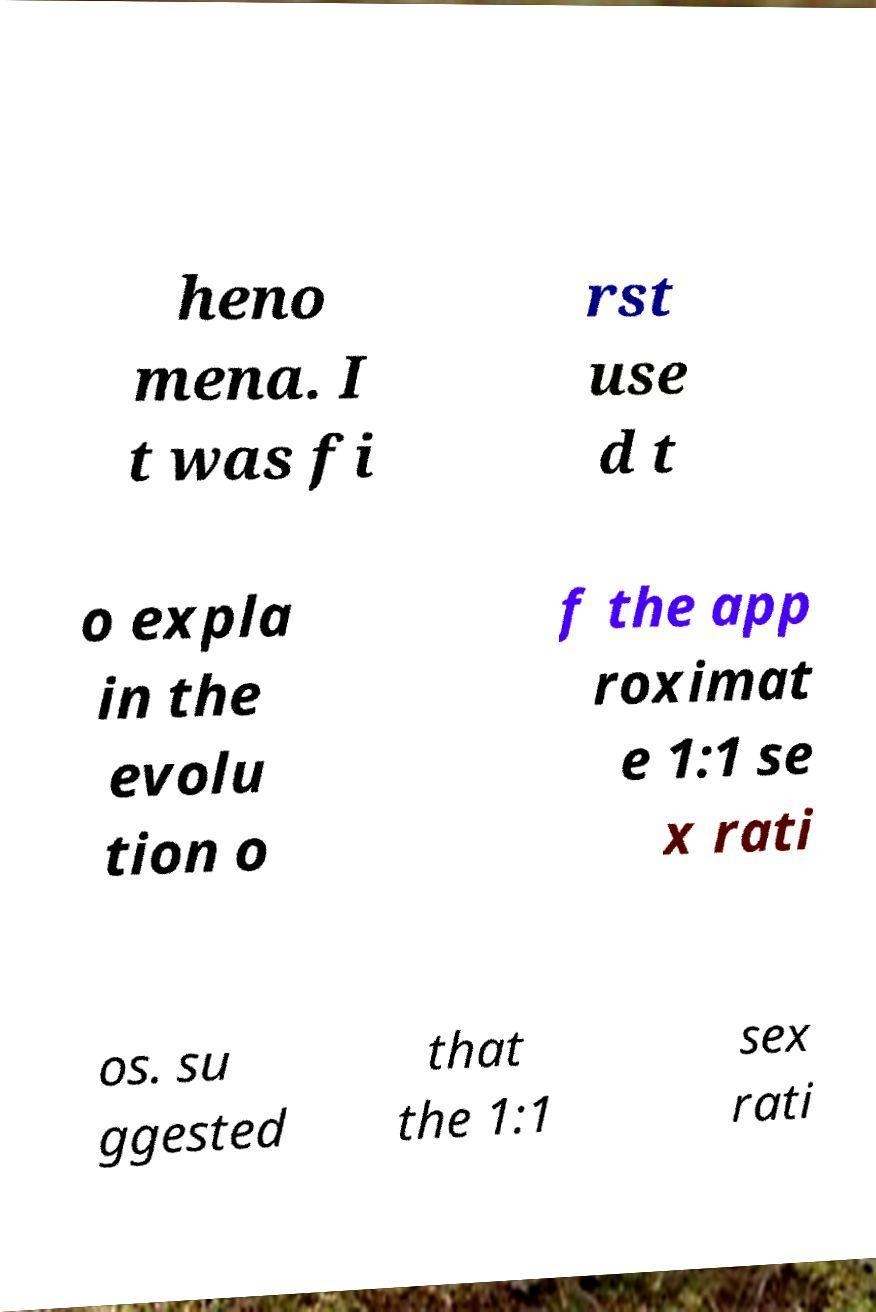Can you accurately transcribe the text from the provided image for me? heno mena. I t was fi rst use d t o expla in the evolu tion o f the app roximat e 1:1 se x rati os. su ggested that the 1:1 sex rati 